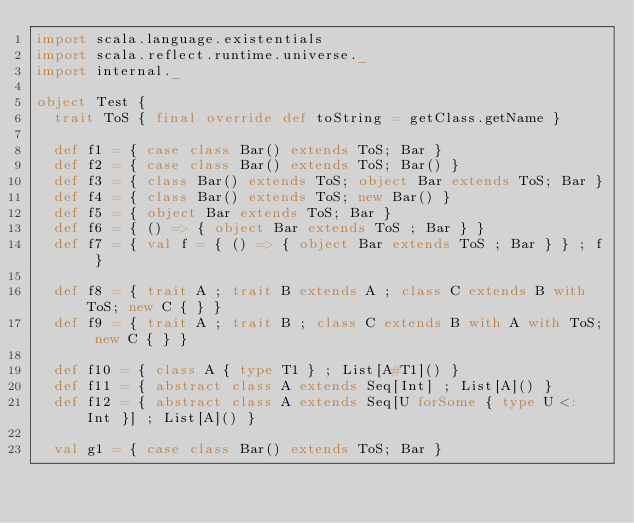Convert code to text. <code><loc_0><loc_0><loc_500><loc_500><_Scala_>import scala.language.existentials
import scala.reflect.runtime.universe._
import internal._

object Test {
  trait ToS { final override def toString = getClass.getName }

  def f1 = { case class Bar() extends ToS; Bar }
  def f2 = { case class Bar() extends ToS; Bar() }
  def f3 = { class Bar() extends ToS; object Bar extends ToS; Bar }
  def f4 = { class Bar() extends ToS; new Bar() }
  def f5 = { object Bar extends ToS; Bar }
  def f6 = { () => { object Bar extends ToS ; Bar } }
  def f7 = { val f = { () => { object Bar extends ToS ; Bar } } ; f }

  def f8 = { trait A ; trait B extends A ; class C extends B with ToS; new C { } }
  def f9 = { trait A ; trait B ; class C extends B with A with ToS; new C { } }

  def f10 = { class A { type T1 } ; List[A#T1]() }
  def f11 = { abstract class A extends Seq[Int] ; List[A]() }
  def f12 = { abstract class A extends Seq[U forSome { type U <: Int }] ; List[A]() }

  val g1 = { case class Bar() extends ToS; Bar }</code> 